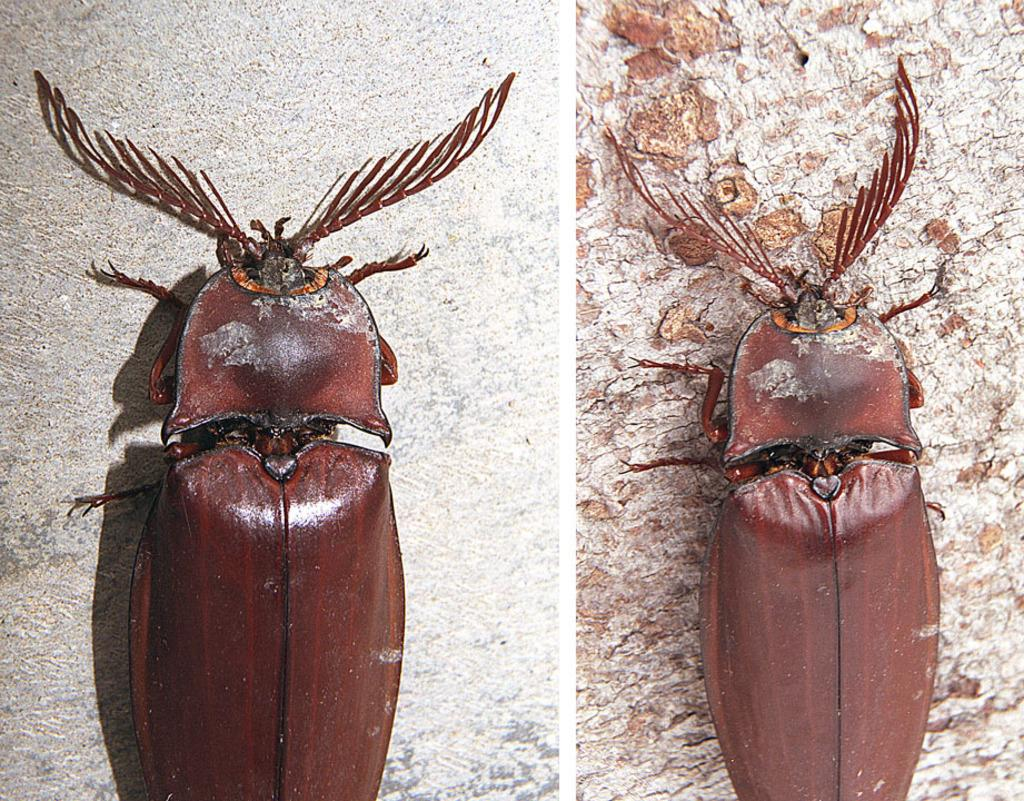What type of artwork is the image? The image is a collage. What type of creature can be seen in the image? There is an insect in the image. Where is the insect located in the image? The insect is on different platforms in the image. What type of committee is responsible for the insect's placement in the image? There is no committee involved in the creation of the image, and the insect's placement is determined by the artist. 